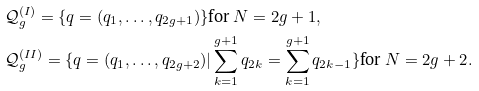Convert formula to latex. <formula><loc_0><loc_0><loc_500><loc_500>& \mathcal { Q } _ { g } ^ { ( I ) } = \{ q = ( q _ { 1 } , \dots , q _ { 2 g + 1 } ) \} \text {for $N=2g+1$} , \\ & \mathcal { Q } _ { g } ^ { ( I I ) } = \{ q = ( q _ { 1 } , \dots , q _ { 2 g + 2 } ) | \sum _ { k = 1 } ^ { g + 1 } q _ { 2 k } = \sum _ { k = 1 } ^ { g + 1 } q _ { 2 k - 1 } \} \text {for $N=2g+2$} .</formula> 